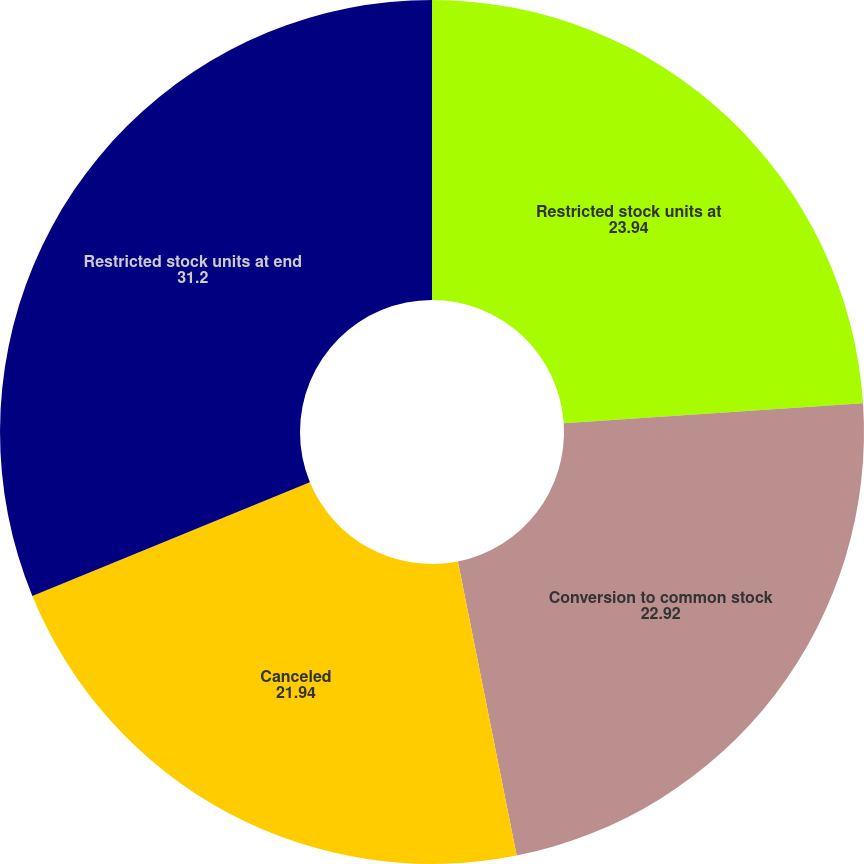<chart> <loc_0><loc_0><loc_500><loc_500><pie_chart><fcel>Restricted stock units at<fcel>Conversion to common stock<fcel>Canceled<fcel>Restricted stock units at end<nl><fcel>23.94%<fcel>22.92%<fcel>21.94%<fcel>31.2%<nl></chart> 